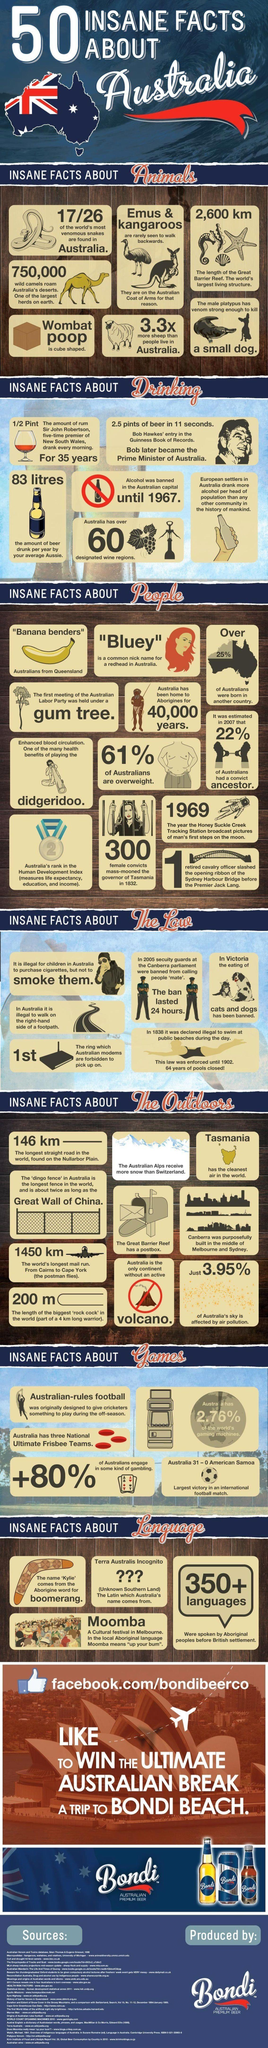What percentage of the world's gaming machines are in Australia?
Answer the question with a short phrase. 2.76% What is the amount of beer drunk per year by an average aussie? 83 litres What was the estimated percentage of Australians who had a convict ancestor in 2007? 22% What is the rank of Australia in the Human Development Index? 2 What is the length of the Great Barrier Reef found in Australia? 2,600 km What is the length of the longest straight road in the world, found on the Nullarbor Plain? 146 km What is the number of female convicts mass-mooned the governor of Tasmania in 1832? 300 Which is the only continent without an active volcano? Australia What percentage of Australians are not overweight? 39% Which state in Australia has the cleanest air in the world? Tasmania 